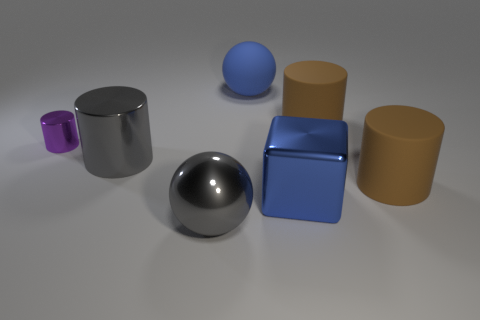Is the number of big blue balls on the right side of the blue shiny object less than the number of big blue metal objects?
Offer a terse response. Yes. What is the size of the gray metal thing in front of the metallic object to the right of the ball that is in front of the blue shiny block?
Offer a very short reply. Large. Are the large brown cylinder that is in front of the small shiny thing and the purple cylinder made of the same material?
Give a very brief answer. No. There is a thing that is the same color as the big metal cube; what is it made of?
Provide a succinct answer. Rubber. Is there anything else that is the same shape as the large blue metal object?
Offer a very short reply. No. What number of things are big gray metal balls or tiny purple cylinders?
Your response must be concise. 2. There is a gray shiny object that is the same shape as the blue matte thing; what size is it?
Provide a short and direct response. Large. Are there any other things that have the same size as the purple metallic thing?
Offer a very short reply. No. What number of other things are the same color as the small cylinder?
Provide a succinct answer. 0. What number of cubes are large metal objects or big gray shiny things?
Your answer should be compact. 1. 